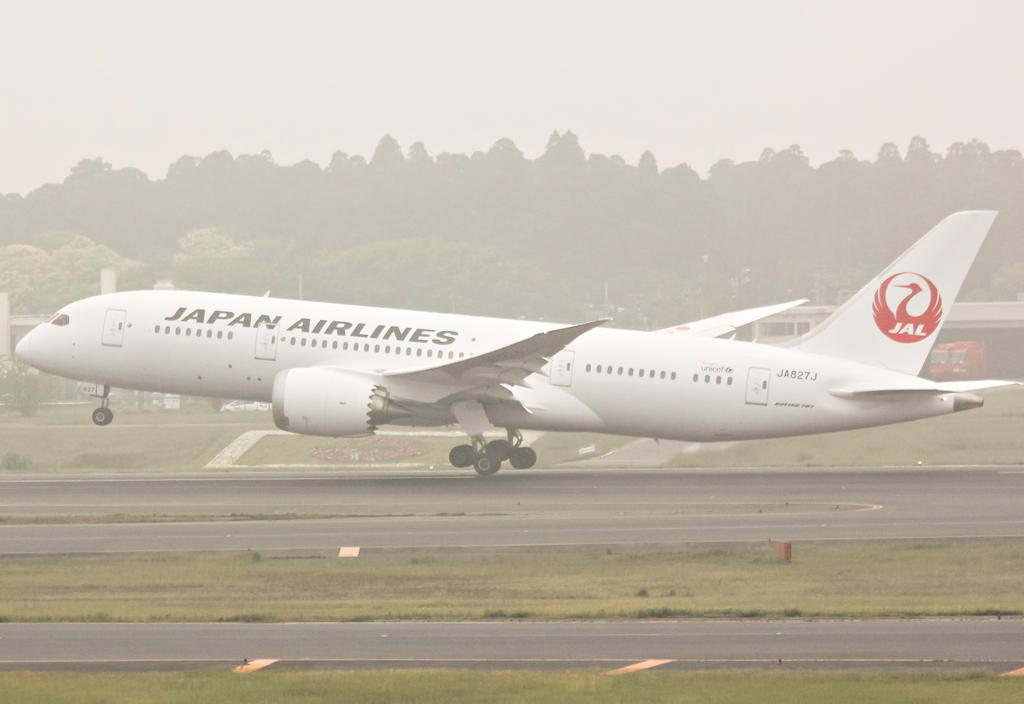What is the main subject of the image? The main subject of the image is an airplane on the runway. Where is the airplane located in the image? The airplane is in the middle of the image. What can be seen in the background of the image? There are trees in the background of the image. What is visible at the top of the image? The sky is visible at the top of the image. What type of parent can be seen in the image? There is no parent present in the image; it features an airplane on the runway. What credit card is being used to pay for the airplane in the image? There is no credit card or payment being made in the image; it simply shows an airplane on the runway. 